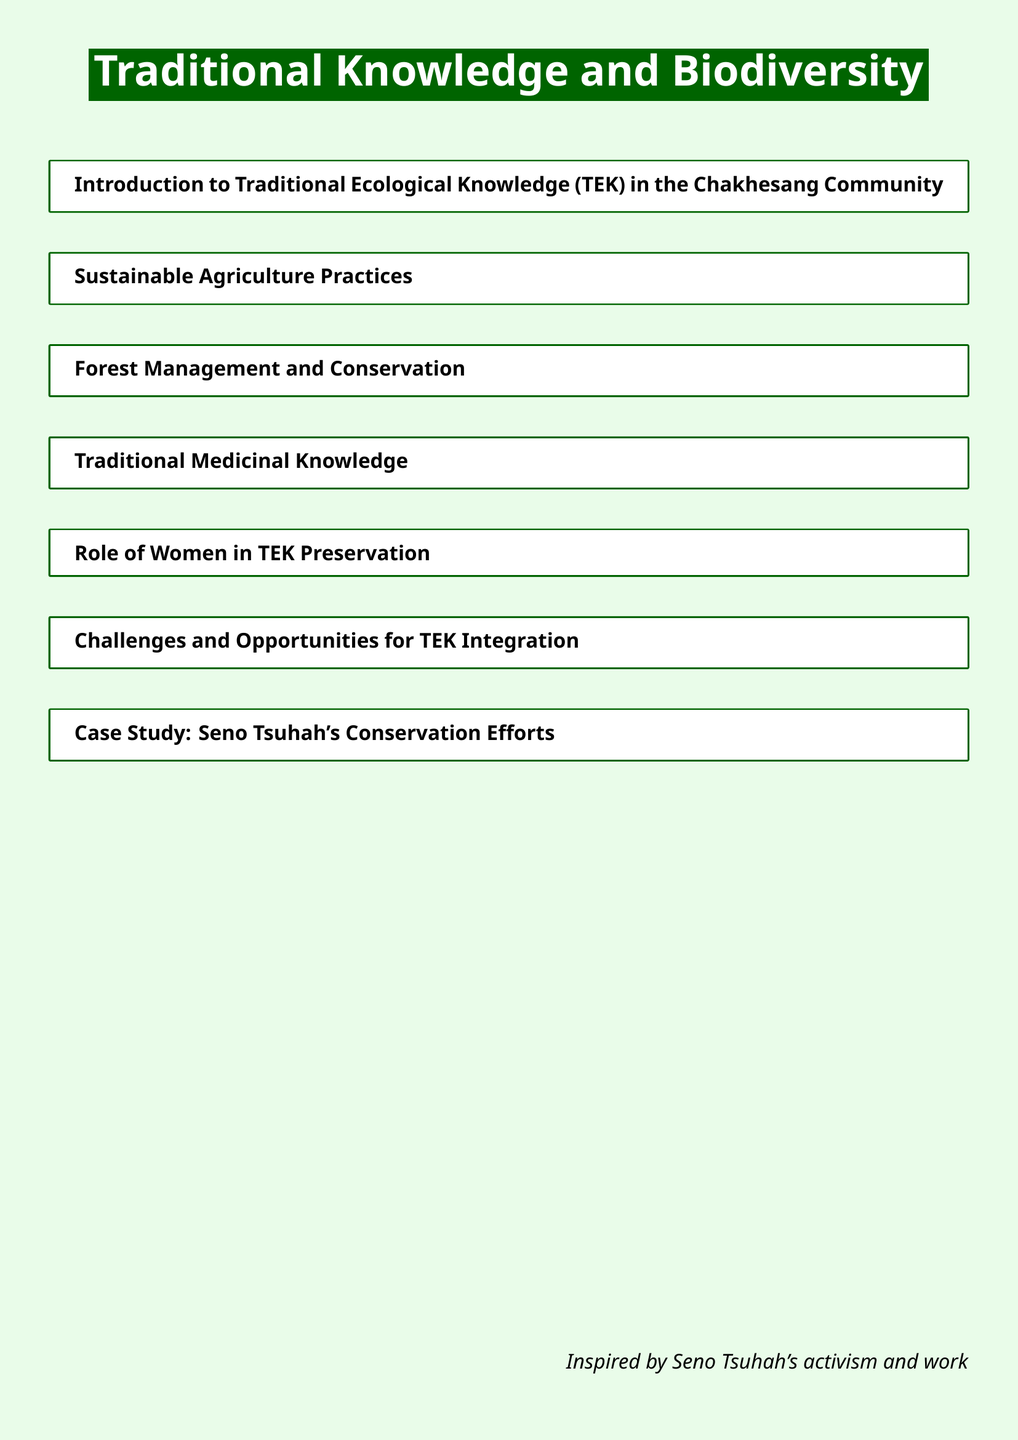What is the title of the document? The title of the document is prominently displayed and indicates the focus of the content.
Answer: Traditional Knowledge and Biodiversity What is one of the sections included in the document? The sections listed in the document provide an outline of the topics covered.
Answer: Sustainable Agriculture Practices Who is highlighted for conservation efforts in a case study? The document includes a specific figure whose activism and work are detailed.
Answer: Seno Tsuhah What is the primary focus of the introduction? The introduction sets the stage for understanding the specific type of knowledge relevant to the community.
Answer: Traditional Ecological Knowledge (TEK) in the Chakhesang Community What roles are discussed in relation to TEK preservation? The document mentions various perspectives on TEK preservation, with a focus on gender.
Answer: Role of Women in TEK Preservation What type of practices does the section on sustainable agriculture discuss? The document covers traditional methods used by the Chakhesang community for ecological balance.
Answer: Sustainable Agriculture Practices What challenge is mentioned regarding TEK? The document identifies obstacles that hinder the integration of traditional knowledge into modern practices.
Answer: Challenges and Opportunities for TEK Integration 